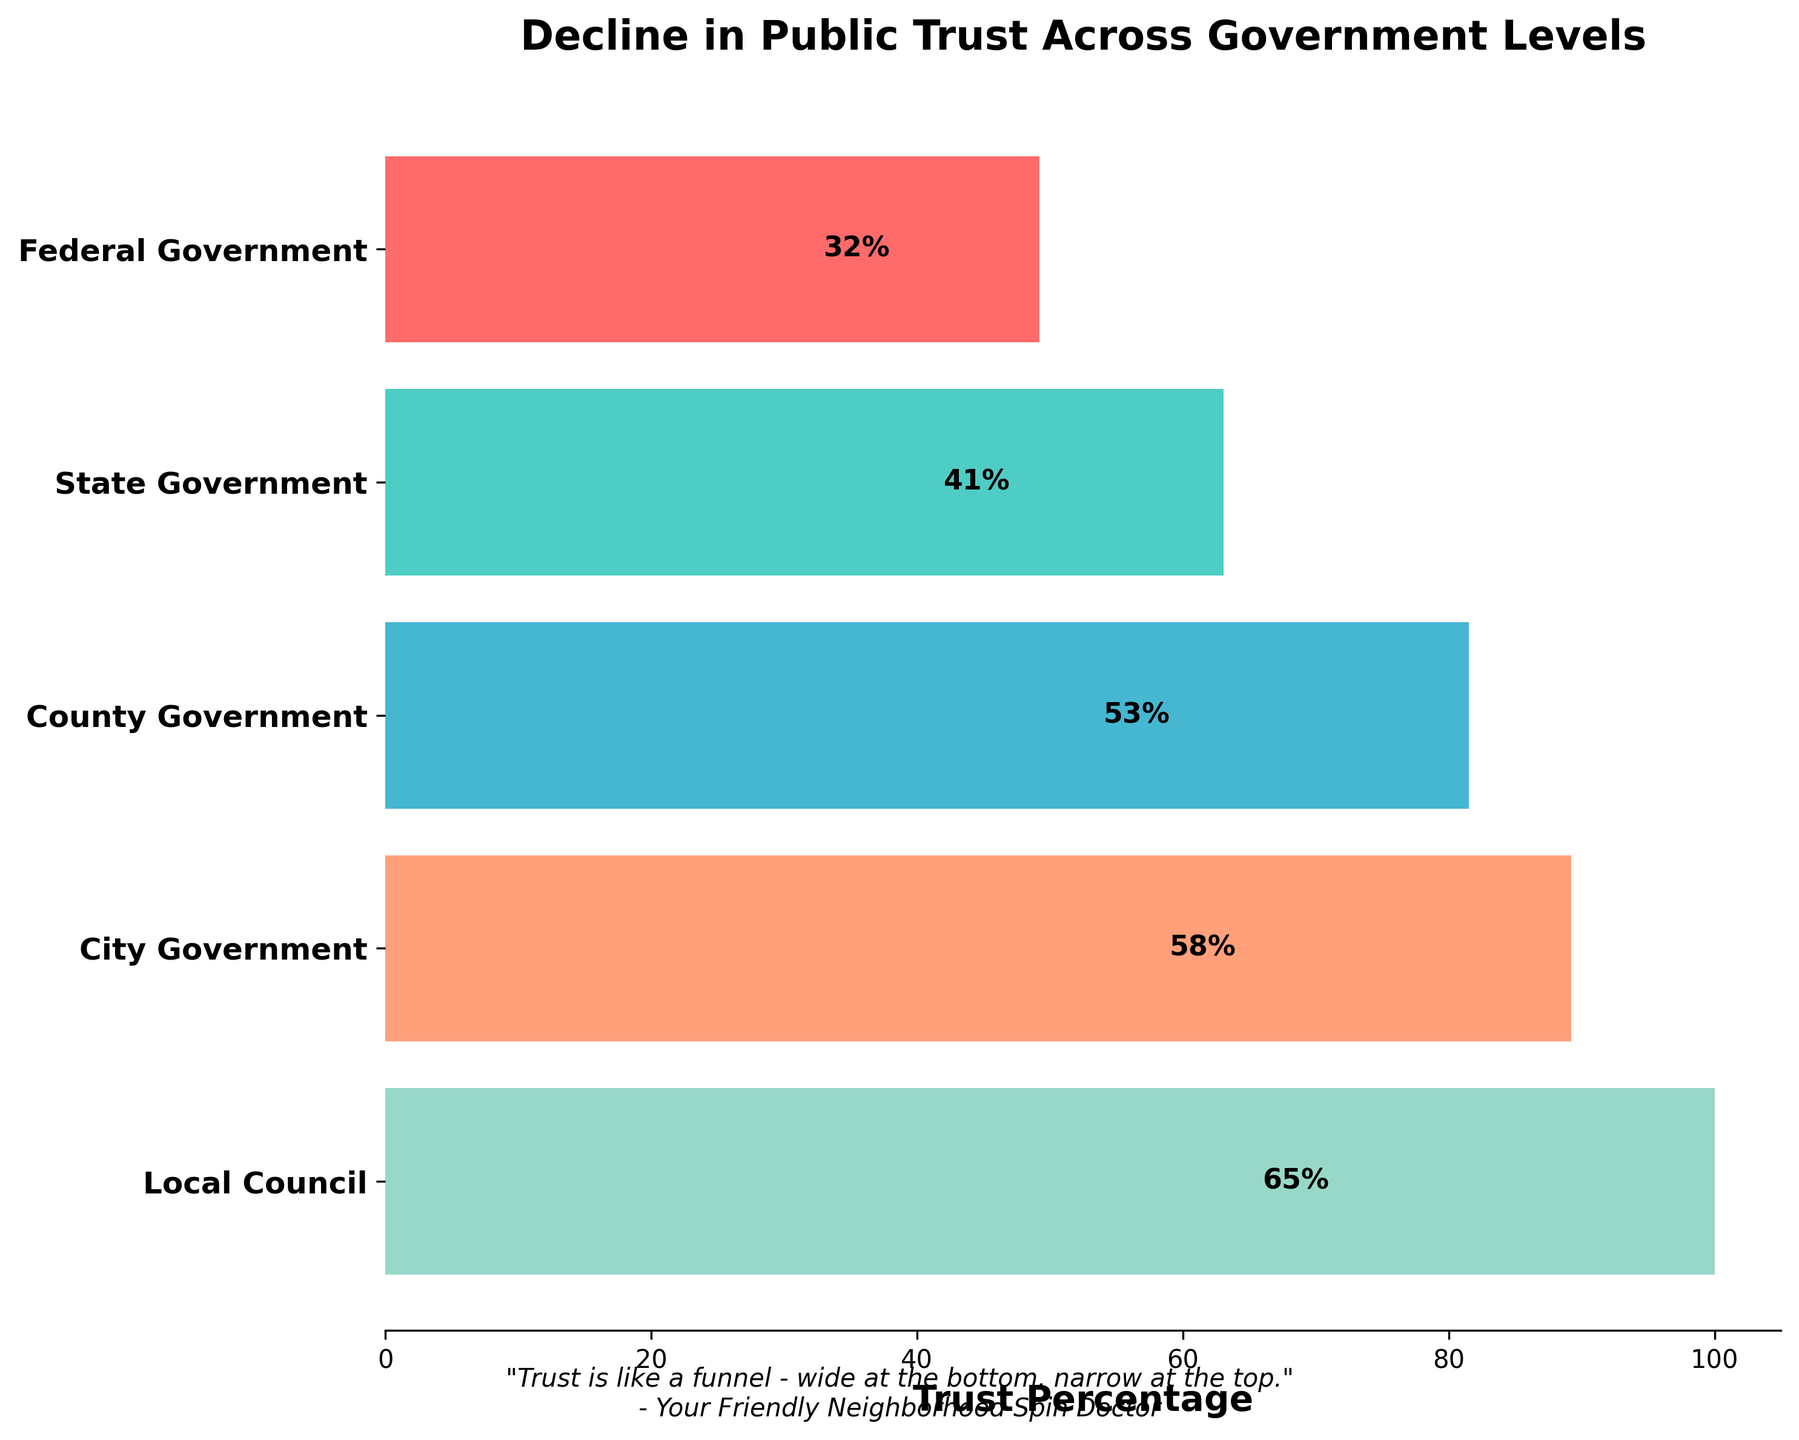How many levels of government are displayed in the funnel chart? The funnel chart displays different levels of government, each with a percentage value. There are 5 unique levels indicated by the horizontal bars.
Answer: 5 Which level of government has the highest trust percentage? Observing the funnel chart, the highest trust percentage is indicated on the largest bar at the bottom of the funnel, labeled "Local Council" with a trust percentage.
Answer: Local Council What's the difference in trust percentages between State and City governments? From the funnel chart, State Government has a trust percentage of 41%, and City Government has a trust percentage of 58%. Calculating the difference: 58% - 41% = 17%.
Answer: 17% What message is conveyed in the subtitle of the chart? The subtitle is located at the bottom of the chart and conveys a metaphorical message. It reads: "Trust is like a funnel - wide at the bottom, narrow at the top." followed by "- Your Friendly Neighborhood Spin Doctor".
Answer: "Trust is like a funnel - wide at the bottom, narrow at the top." Which trust percentage is closest to the median value of the displayed percentages? The displayed trust percentages are 32%, 41%, 53%, 58%, and 65%. Arranging them in ascending order: 32%, 41%, 53%, 58%, 65%, the median value is the middle one, which is 53%.
Answer: 53% Compare trust in the Federal Government to trust in the County Government. Which is higher and by how much? Federal Government has a trust percentage of 32%, while County Government has 53%. Comparing the two, 53% (County Government) is higher by 53% - 32% = 21%.
Answer: County Government by 21% What is the title of the funnel chart? The title of the chart is located prominently at the top. It reads "Decline in Public Trust Across Government Levels".
Answer: Decline in Public Trust Across Government Levels What trust percentage does the State Government have? The funnel chart indicates trust percentages for each government level, listing the State Government with a specific value. The corresponding bar for State Government notes a percentage of 41%.
Answer: 41% How much more trusted is the Local Council compared to the Federal Government? Local Council has a trust percentage of 65%, whereas Federal Government has 32%. The difference between these values is 65% - 32% = 33%.
Answer: 33% Identify the color representing the City Government in the funnel chart. The funnel chart uses different colors for each government level. The bar representing the City Government is typically shown with a unique color, often distinguishable by hue or shade. The color in this case is a light orange shade.
Answer: Light Orange 